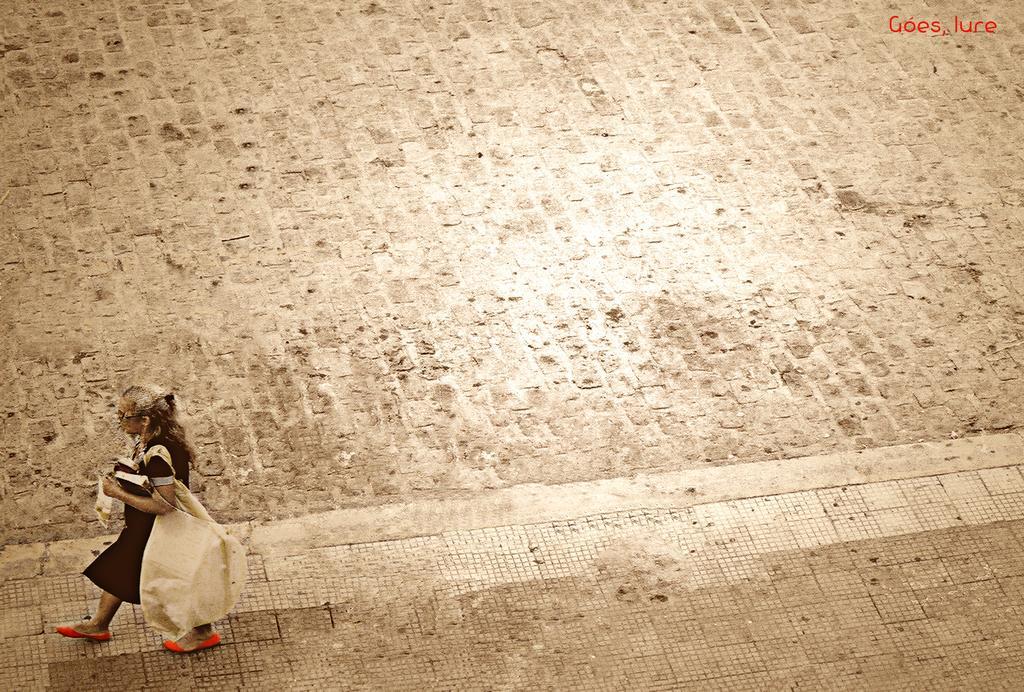How would you summarize this image in a sentence or two? In this image, we can see a person carrying a bag. We can see the ground and some text on the top right corner. 